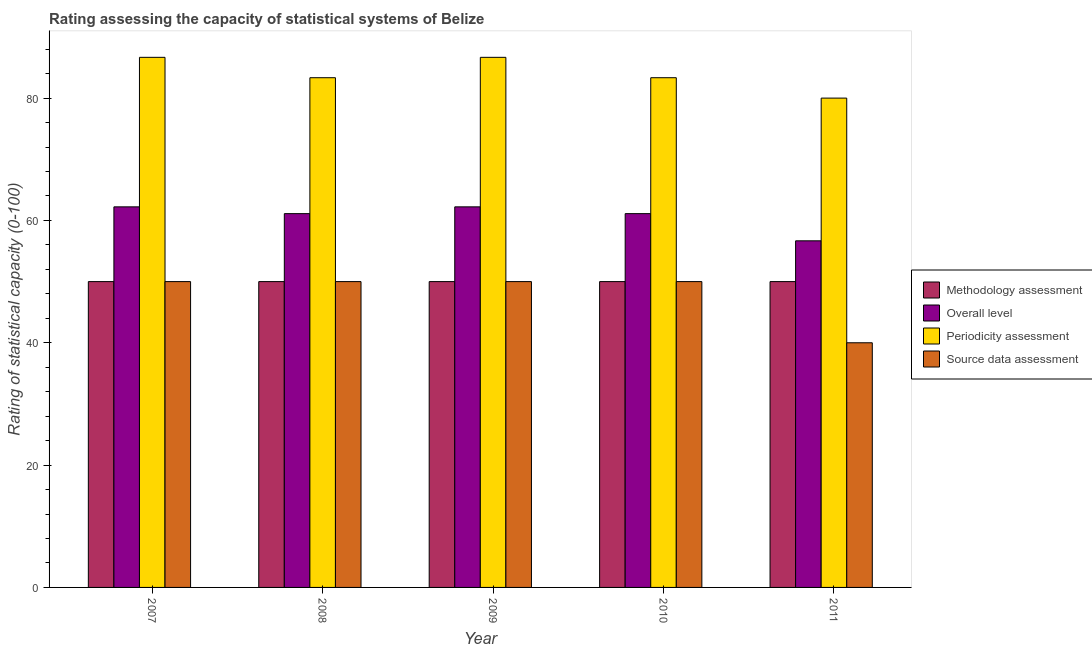How many groups of bars are there?
Offer a terse response. 5. How many bars are there on the 2nd tick from the left?
Offer a terse response. 4. In how many cases, is the number of bars for a given year not equal to the number of legend labels?
Offer a terse response. 0. What is the periodicity assessment rating in 2008?
Offer a terse response. 83.33. Across all years, what is the maximum periodicity assessment rating?
Keep it short and to the point. 86.67. Across all years, what is the minimum methodology assessment rating?
Offer a terse response. 50. In which year was the methodology assessment rating maximum?
Offer a terse response. 2007. What is the total overall level rating in the graph?
Provide a succinct answer. 303.33. What is the difference between the source data assessment rating in 2007 and that in 2011?
Your answer should be very brief. 10. What is the difference between the periodicity assessment rating in 2008 and the methodology assessment rating in 2007?
Your answer should be very brief. -3.33. In how many years, is the methodology assessment rating greater than 76?
Keep it short and to the point. 0. Is the source data assessment rating in 2009 less than that in 2010?
Provide a short and direct response. No. What is the difference between the highest and the second highest periodicity assessment rating?
Offer a very short reply. 0. What is the difference between the highest and the lowest source data assessment rating?
Provide a short and direct response. 10. In how many years, is the methodology assessment rating greater than the average methodology assessment rating taken over all years?
Provide a succinct answer. 0. Is the sum of the periodicity assessment rating in 2007 and 2008 greater than the maximum methodology assessment rating across all years?
Offer a very short reply. Yes. Is it the case that in every year, the sum of the periodicity assessment rating and overall level rating is greater than the sum of methodology assessment rating and source data assessment rating?
Offer a terse response. Yes. What does the 3rd bar from the left in 2009 represents?
Make the answer very short. Periodicity assessment. What does the 1st bar from the right in 2007 represents?
Offer a terse response. Source data assessment. How many bars are there?
Give a very brief answer. 20. Are all the bars in the graph horizontal?
Offer a very short reply. No. What is the difference between two consecutive major ticks on the Y-axis?
Offer a terse response. 20. Does the graph contain grids?
Your response must be concise. No. Where does the legend appear in the graph?
Make the answer very short. Center right. How are the legend labels stacked?
Ensure brevity in your answer.  Vertical. What is the title of the graph?
Give a very brief answer. Rating assessing the capacity of statistical systems of Belize. Does "Permission" appear as one of the legend labels in the graph?
Make the answer very short. No. What is the label or title of the X-axis?
Give a very brief answer. Year. What is the label or title of the Y-axis?
Offer a very short reply. Rating of statistical capacity (0-100). What is the Rating of statistical capacity (0-100) of Overall level in 2007?
Ensure brevity in your answer.  62.22. What is the Rating of statistical capacity (0-100) in Periodicity assessment in 2007?
Make the answer very short. 86.67. What is the Rating of statistical capacity (0-100) in Methodology assessment in 2008?
Make the answer very short. 50. What is the Rating of statistical capacity (0-100) in Overall level in 2008?
Give a very brief answer. 61.11. What is the Rating of statistical capacity (0-100) in Periodicity assessment in 2008?
Provide a short and direct response. 83.33. What is the Rating of statistical capacity (0-100) in Source data assessment in 2008?
Give a very brief answer. 50. What is the Rating of statistical capacity (0-100) of Overall level in 2009?
Keep it short and to the point. 62.22. What is the Rating of statistical capacity (0-100) in Periodicity assessment in 2009?
Your answer should be compact. 86.67. What is the Rating of statistical capacity (0-100) of Methodology assessment in 2010?
Provide a succinct answer. 50. What is the Rating of statistical capacity (0-100) in Overall level in 2010?
Keep it short and to the point. 61.11. What is the Rating of statistical capacity (0-100) of Periodicity assessment in 2010?
Ensure brevity in your answer.  83.33. What is the Rating of statistical capacity (0-100) of Overall level in 2011?
Offer a terse response. 56.67. Across all years, what is the maximum Rating of statistical capacity (0-100) in Overall level?
Give a very brief answer. 62.22. Across all years, what is the maximum Rating of statistical capacity (0-100) in Periodicity assessment?
Your answer should be compact. 86.67. Across all years, what is the maximum Rating of statistical capacity (0-100) in Source data assessment?
Your response must be concise. 50. Across all years, what is the minimum Rating of statistical capacity (0-100) of Methodology assessment?
Ensure brevity in your answer.  50. Across all years, what is the minimum Rating of statistical capacity (0-100) in Overall level?
Give a very brief answer. 56.67. Across all years, what is the minimum Rating of statistical capacity (0-100) of Periodicity assessment?
Your answer should be very brief. 80. What is the total Rating of statistical capacity (0-100) of Methodology assessment in the graph?
Give a very brief answer. 250. What is the total Rating of statistical capacity (0-100) of Overall level in the graph?
Provide a short and direct response. 303.33. What is the total Rating of statistical capacity (0-100) of Periodicity assessment in the graph?
Your answer should be very brief. 420. What is the total Rating of statistical capacity (0-100) in Source data assessment in the graph?
Provide a short and direct response. 240. What is the difference between the Rating of statistical capacity (0-100) in Overall level in 2007 and that in 2008?
Offer a very short reply. 1.11. What is the difference between the Rating of statistical capacity (0-100) in Source data assessment in 2007 and that in 2008?
Your answer should be compact. 0. What is the difference between the Rating of statistical capacity (0-100) of Methodology assessment in 2007 and that in 2009?
Your answer should be very brief. 0. What is the difference between the Rating of statistical capacity (0-100) in Periodicity assessment in 2007 and that in 2010?
Give a very brief answer. 3.33. What is the difference between the Rating of statistical capacity (0-100) of Source data assessment in 2007 and that in 2010?
Keep it short and to the point. 0. What is the difference between the Rating of statistical capacity (0-100) of Overall level in 2007 and that in 2011?
Your answer should be very brief. 5.56. What is the difference between the Rating of statistical capacity (0-100) of Source data assessment in 2007 and that in 2011?
Give a very brief answer. 10. What is the difference between the Rating of statistical capacity (0-100) of Overall level in 2008 and that in 2009?
Ensure brevity in your answer.  -1.11. What is the difference between the Rating of statistical capacity (0-100) of Source data assessment in 2008 and that in 2009?
Keep it short and to the point. 0. What is the difference between the Rating of statistical capacity (0-100) in Methodology assessment in 2008 and that in 2010?
Offer a very short reply. 0. What is the difference between the Rating of statistical capacity (0-100) of Overall level in 2008 and that in 2010?
Give a very brief answer. 0. What is the difference between the Rating of statistical capacity (0-100) of Source data assessment in 2008 and that in 2010?
Provide a short and direct response. 0. What is the difference between the Rating of statistical capacity (0-100) of Methodology assessment in 2008 and that in 2011?
Make the answer very short. 0. What is the difference between the Rating of statistical capacity (0-100) in Overall level in 2008 and that in 2011?
Keep it short and to the point. 4.44. What is the difference between the Rating of statistical capacity (0-100) of Source data assessment in 2008 and that in 2011?
Keep it short and to the point. 10. What is the difference between the Rating of statistical capacity (0-100) in Methodology assessment in 2009 and that in 2010?
Your response must be concise. 0. What is the difference between the Rating of statistical capacity (0-100) of Overall level in 2009 and that in 2010?
Provide a succinct answer. 1.11. What is the difference between the Rating of statistical capacity (0-100) of Periodicity assessment in 2009 and that in 2010?
Give a very brief answer. 3.33. What is the difference between the Rating of statistical capacity (0-100) in Overall level in 2009 and that in 2011?
Your answer should be compact. 5.56. What is the difference between the Rating of statistical capacity (0-100) of Source data assessment in 2009 and that in 2011?
Provide a short and direct response. 10. What is the difference between the Rating of statistical capacity (0-100) of Methodology assessment in 2010 and that in 2011?
Provide a short and direct response. 0. What is the difference between the Rating of statistical capacity (0-100) of Overall level in 2010 and that in 2011?
Your answer should be compact. 4.44. What is the difference between the Rating of statistical capacity (0-100) in Periodicity assessment in 2010 and that in 2011?
Keep it short and to the point. 3.33. What is the difference between the Rating of statistical capacity (0-100) of Source data assessment in 2010 and that in 2011?
Provide a short and direct response. 10. What is the difference between the Rating of statistical capacity (0-100) of Methodology assessment in 2007 and the Rating of statistical capacity (0-100) of Overall level in 2008?
Provide a succinct answer. -11.11. What is the difference between the Rating of statistical capacity (0-100) of Methodology assessment in 2007 and the Rating of statistical capacity (0-100) of Periodicity assessment in 2008?
Offer a very short reply. -33.33. What is the difference between the Rating of statistical capacity (0-100) of Overall level in 2007 and the Rating of statistical capacity (0-100) of Periodicity assessment in 2008?
Provide a short and direct response. -21.11. What is the difference between the Rating of statistical capacity (0-100) of Overall level in 2007 and the Rating of statistical capacity (0-100) of Source data assessment in 2008?
Make the answer very short. 12.22. What is the difference between the Rating of statistical capacity (0-100) of Periodicity assessment in 2007 and the Rating of statistical capacity (0-100) of Source data assessment in 2008?
Your answer should be compact. 36.67. What is the difference between the Rating of statistical capacity (0-100) in Methodology assessment in 2007 and the Rating of statistical capacity (0-100) in Overall level in 2009?
Provide a short and direct response. -12.22. What is the difference between the Rating of statistical capacity (0-100) in Methodology assessment in 2007 and the Rating of statistical capacity (0-100) in Periodicity assessment in 2009?
Provide a succinct answer. -36.67. What is the difference between the Rating of statistical capacity (0-100) in Overall level in 2007 and the Rating of statistical capacity (0-100) in Periodicity assessment in 2009?
Keep it short and to the point. -24.44. What is the difference between the Rating of statistical capacity (0-100) of Overall level in 2007 and the Rating of statistical capacity (0-100) of Source data assessment in 2009?
Your answer should be very brief. 12.22. What is the difference between the Rating of statistical capacity (0-100) of Periodicity assessment in 2007 and the Rating of statistical capacity (0-100) of Source data assessment in 2009?
Your response must be concise. 36.67. What is the difference between the Rating of statistical capacity (0-100) in Methodology assessment in 2007 and the Rating of statistical capacity (0-100) in Overall level in 2010?
Ensure brevity in your answer.  -11.11. What is the difference between the Rating of statistical capacity (0-100) of Methodology assessment in 2007 and the Rating of statistical capacity (0-100) of Periodicity assessment in 2010?
Make the answer very short. -33.33. What is the difference between the Rating of statistical capacity (0-100) of Methodology assessment in 2007 and the Rating of statistical capacity (0-100) of Source data assessment in 2010?
Ensure brevity in your answer.  0. What is the difference between the Rating of statistical capacity (0-100) in Overall level in 2007 and the Rating of statistical capacity (0-100) in Periodicity assessment in 2010?
Ensure brevity in your answer.  -21.11. What is the difference between the Rating of statistical capacity (0-100) of Overall level in 2007 and the Rating of statistical capacity (0-100) of Source data assessment in 2010?
Give a very brief answer. 12.22. What is the difference between the Rating of statistical capacity (0-100) in Periodicity assessment in 2007 and the Rating of statistical capacity (0-100) in Source data assessment in 2010?
Offer a terse response. 36.67. What is the difference between the Rating of statistical capacity (0-100) in Methodology assessment in 2007 and the Rating of statistical capacity (0-100) in Overall level in 2011?
Offer a very short reply. -6.67. What is the difference between the Rating of statistical capacity (0-100) of Overall level in 2007 and the Rating of statistical capacity (0-100) of Periodicity assessment in 2011?
Your answer should be very brief. -17.78. What is the difference between the Rating of statistical capacity (0-100) of Overall level in 2007 and the Rating of statistical capacity (0-100) of Source data assessment in 2011?
Give a very brief answer. 22.22. What is the difference between the Rating of statistical capacity (0-100) of Periodicity assessment in 2007 and the Rating of statistical capacity (0-100) of Source data assessment in 2011?
Keep it short and to the point. 46.67. What is the difference between the Rating of statistical capacity (0-100) in Methodology assessment in 2008 and the Rating of statistical capacity (0-100) in Overall level in 2009?
Your answer should be very brief. -12.22. What is the difference between the Rating of statistical capacity (0-100) of Methodology assessment in 2008 and the Rating of statistical capacity (0-100) of Periodicity assessment in 2009?
Give a very brief answer. -36.67. What is the difference between the Rating of statistical capacity (0-100) in Overall level in 2008 and the Rating of statistical capacity (0-100) in Periodicity assessment in 2009?
Provide a short and direct response. -25.56. What is the difference between the Rating of statistical capacity (0-100) of Overall level in 2008 and the Rating of statistical capacity (0-100) of Source data assessment in 2009?
Provide a succinct answer. 11.11. What is the difference between the Rating of statistical capacity (0-100) in Periodicity assessment in 2008 and the Rating of statistical capacity (0-100) in Source data assessment in 2009?
Provide a short and direct response. 33.33. What is the difference between the Rating of statistical capacity (0-100) of Methodology assessment in 2008 and the Rating of statistical capacity (0-100) of Overall level in 2010?
Your response must be concise. -11.11. What is the difference between the Rating of statistical capacity (0-100) in Methodology assessment in 2008 and the Rating of statistical capacity (0-100) in Periodicity assessment in 2010?
Provide a succinct answer. -33.33. What is the difference between the Rating of statistical capacity (0-100) of Overall level in 2008 and the Rating of statistical capacity (0-100) of Periodicity assessment in 2010?
Give a very brief answer. -22.22. What is the difference between the Rating of statistical capacity (0-100) of Overall level in 2008 and the Rating of statistical capacity (0-100) of Source data assessment in 2010?
Provide a short and direct response. 11.11. What is the difference between the Rating of statistical capacity (0-100) in Periodicity assessment in 2008 and the Rating of statistical capacity (0-100) in Source data assessment in 2010?
Your answer should be very brief. 33.33. What is the difference between the Rating of statistical capacity (0-100) of Methodology assessment in 2008 and the Rating of statistical capacity (0-100) of Overall level in 2011?
Offer a very short reply. -6.67. What is the difference between the Rating of statistical capacity (0-100) of Methodology assessment in 2008 and the Rating of statistical capacity (0-100) of Periodicity assessment in 2011?
Provide a succinct answer. -30. What is the difference between the Rating of statistical capacity (0-100) of Methodology assessment in 2008 and the Rating of statistical capacity (0-100) of Source data assessment in 2011?
Provide a succinct answer. 10. What is the difference between the Rating of statistical capacity (0-100) in Overall level in 2008 and the Rating of statistical capacity (0-100) in Periodicity assessment in 2011?
Keep it short and to the point. -18.89. What is the difference between the Rating of statistical capacity (0-100) in Overall level in 2008 and the Rating of statistical capacity (0-100) in Source data assessment in 2011?
Your response must be concise. 21.11. What is the difference between the Rating of statistical capacity (0-100) in Periodicity assessment in 2008 and the Rating of statistical capacity (0-100) in Source data assessment in 2011?
Keep it short and to the point. 43.33. What is the difference between the Rating of statistical capacity (0-100) of Methodology assessment in 2009 and the Rating of statistical capacity (0-100) of Overall level in 2010?
Keep it short and to the point. -11.11. What is the difference between the Rating of statistical capacity (0-100) in Methodology assessment in 2009 and the Rating of statistical capacity (0-100) in Periodicity assessment in 2010?
Offer a very short reply. -33.33. What is the difference between the Rating of statistical capacity (0-100) in Methodology assessment in 2009 and the Rating of statistical capacity (0-100) in Source data assessment in 2010?
Offer a terse response. 0. What is the difference between the Rating of statistical capacity (0-100) of Overall level in 2009 and the Rating of statistical capacity (0-100) of Periodicity assessment in 2010?
Your answer should be very brief. -21.11. What is the difference between the Rating of statistical capacity (0-100) in Overall level in 2009 and the Rating of statistical capacity (0-100) in Source data assessment in 2010?
Keep it short and to the point. 12.22. What is the difference between the Rating of statistical capacity (0-100) of Periodicity assessment in 2009 and the Rating of statistical capacity (0-100) of Source data assessment in 2010?
Give a very brief answer. 36.67. What is the difference between the Rating of statistical capacity (0-100) in Methodology assessment in 2009 and the Rating of statistical capacity (0-100) in Overall level in 2011?
Make the answer very short. -6.67. What is the difference between the Rating of statistical capacity (0-100) in Methodology assessment in 2009 and the Rating of statistical capacity (0-100) in Periodicity assessment in 2011?
Ensure brevity in your answer.  -30. What is the difference between the Rating of statistical capacity (0-100) in Overall level in 2009 and the Rating of statistical capacity (0-100) in Periodicity assessment in 2011?
Make the answer very short. -17.78. What is the difference between the Rating of statistical capacity (0-100) of Overall level in 2009 and the Rating of statistical capacity (0-100) of Source data assessment in 2011?
Give a very brief answer. 22.22. What is the difference between the Rating of statistical capacity (0-100) of Periodicity assessment in 2009 and the Rating of statistical capacity (0-100) of Source data assessment in 2011?
Keep it short and to the point. 46.67. What is the difference between the Rating of statistical capacity (0-100) of Methodology assessment in 2010 and the Rating of statistical capacity (0-100) of Overall level in 2011?
Your response must be concise. -6.67. What is the difference between the Rating of statistical capacity (0-100) of Overall level in 2010 and the Rating of statistical capacity (0-100) of Periodicity assessment in 2011?
Offer a terse response. -18.89. What is the difference between the Rating of statistical capacity (0-100) in Overall level in 2010 and the Rating of statistical capacity (0-100) in Source data assessment in 2011?
Provide a succinct answer. 21.11. What is the difference between the Rating of statistical capacity (0-100) of Periodicity assessment in 2010 and the Rating of statistical capacity (0-100) of Source data assessment in 2011?
Your answer should be very brief. 43.33. What is the average Rating of statistical capacity (0-100) of Methodology assessment per year?
Ensure brevity in your answer.  50. What is the average Rating of statistical capacity (0-100) in Overall level per year?
Your answer should be compact. 60.67. In the year 2007, what is the difference between the Rating of statistical capacity (0-100) of Methodology assessment and Rating of statistical capacity (0-100) of Overall level?
Your answer should be compact. -12.22. In the year 2007, what is the difference between the Rating of statistical capacity (0-100) of Methodology assessment and Rating of statistical capacity (0-100) of Periodicity assessment?
Ensure brevity in your answer.  -36.67. In the year 2007, what is the difference between the Rating of statistical capacity (0-100) in Methodology assessment and Rating of statistical capacity (0-100) in Source data assessment?
Your answer should be very brief. 0. In the year 2007, what is the difference between the Rating of statistical capacity (0-100) of Overall level and Rating of statistical capacity (0-100) of Periodicity assessment?
Your response must be concise. -24.44. In the year 2007, what is the difference between the Rating of statistical capacity (0-100) in Overall level and Rating of statistical capacity (0-100) in Source data assessment?
Make the answer very short. 12.22. In the year 2007, what is the difference between the Rating of statistical capacity (0-100) in Periodicity assessment and Rating of statistical capacity (0-100) in Source data assessment?
Ensure brevity in your answer.  36.67. In the year 2008, what is the difference between the Rating of statistical capacity (0-100) of Methodology assessment and Rating of statistical capacity (0-100) of Overall level?
Keep it short and to the point. -11.11. In the year 2008, what is the difference between the Rating of statistical capacity (0-100) of Methodology assessment and Rating of statistical capacity (0-100) of Periodicity assessment?
Make the answer very short. -33.33. In the year 2008, what is the difference between the Rating of statistical capacity (0-100) in Methodology assessment and Rating of statistical capacity (0-100) in Source data assessment?
Give a very brief answer. 0. In the year 2008, what is the difference between the Rating of statistical capacity (0-100) of Overall level and Rating of statistical capacity (0-100) of Periodicity assessment?
Provide a short and direct response. -22.22. In the year 2008, what is the difference between the Rating of statistical capacity (0-100) of Overall level and Rating of statistical capacity (0-100) of Source data assessment?
Ensure brevity in your answer.  11.11. In the year 2008, what is the difference between the Rating of statistical capacity (0-100) of Periodicity assessment and Rating of statistical capacity (0-100) of Source data assessment?
Ensure brevity in your answer.  33.33. In the year 2009, what is the difference between the Rating of statistical capacity (0-100) in Methodology assessment and Rating of statistical capacity (0-100) in Overall level?
Ensure brevity in your answer.  -12.22. In the year 2009, what is the difference between the Rating of statistical capacity (0-100) in Methodology assessment and Rating of statistical capacity (0-100) in Periodicity assessment?
Your answer should be very brief. -36.67. In the year 2009, what is the difference between the Rating of statistical capacity (0-100) in Overall level and Rating of statistical capacity (0-100) in Periodicity assessment?
Your answer should be very brief. -24.44. In the year 2009, what is the difference between the Rating of statistical capacity (0-100) of Overall level and Rating of statistical capacity (0-100) of Source data assessment?
Offer a terse response. 12.22. In the year 2009, what is the difference between the Rating of statistical capacity (0-100) in Periodicity assessment and Rating of statistical capacity (0-100) in Source data assessment?
Ensure brevity in your answer.  36.67. In the year 2010, what is the difference between the Rating of statistical capacity (0-100) in Methodology assessment and Rating of statistical capacity (0-100) in Overall level?
Offer a very short reply. -11.11. In the year 2010, what is the difference between the Rating of statistical capacity (0-100) of Methodology assessment and Rating of statistical capacity (0-100) of Periodicity assessment?
Make the answer very short. -33.33. In the year 2010, what is the difference between the Rating of statistical capacity (0-100) in Methodology assessment and Rating of statistical capacity (0-100) in Source data assessment?
Your response must be concise. 0. In the year 2010, what is the difference between the Rating of statistical capacity (0-100) in Overall level and Rating of statistical capacity (0-100) in Periodicity assessment?
Make the answer very short. -22.22. In the year 2010, what is the difference between the Rating of statistical capacity (0-100) of Overall level and Rating of statistical capacity (0-100) of Source data assessment?
Offer a very short reply. 11.11. In the year 2010, what is the difference between the Rating of statistical capacity (0-100) in Periodicity assessment and Rating of statistical capacity (0-100) in Source data assessment?
Ensure brevity in your answer.  33.33. In the year 2011, what is the difference between the Rating of statistical capacity (0-100) of Methodology assessment and Rating of statistical capacity (0-100) of Overall level?
Your answer should be very brief. -6.67. In the year 2011, what is the difference between the Rating of statistical capacity (0-100) of Methodology assessment and Rating of statistical capacity (0-100) of Periodicity assessment?
Your answer should be very brief. -30. In the year 2011, what is the difference between the Rating of statistical capacity (0-100) in Methodology assessment and Rating of statistical capacity (0-100) in Source data assessment?
Give a very brief answer. 10. In the year 2011, what is the difference between the Rating of statistical capacity (0-100) in Overall level and Rating of statistical capacity (0-100) in Periodicity assessment?
Your answer should be compact. -23.33. In the year 2011, what is the difference between the Rating of statistical capacity (0-100) of Overall level and Rating of statistical capacity (0-100) of Source data assessment?
Provide a short and direct response. 16.67. In the year 2011, what is the difference between the Rating of statistical capacity (0-100) of Periodicity assessment and Rating of statistical capacity (0-100) of Source data assessment?
Your answer should be compact. 40. What is the ratio of the Rating of statistical capacity (0-100) in Overall level in 2007 to that in 2008?
Keep it short and to the point. 1.02. What is the ratio of the Rating of statistical capacity (0-100) of Source data assessment in 2007 to that in 2008?
Ensure brevity in your answer.  1. What is the ratio of the Rating of statistical capacity (0-100) of Methodology assessment in 2007 to that in 2009?
Make the answer very short. 1. What is the ratio of the Rating of statistical capacity (0-100) of Overall level in 2007 to that in 2009?
Give a very brief answer. 1. What is the ratio of the Rating of statistical capacity (0-100) in Source data assessment in 2007 to that in 2009?
Offer a terse response. 1. What is the ratio of the Rating of statistical capacity (0-100) of Methodology assessment in 2007 to that in 2010?
Provide a short and direct response. 1. What is the ratio of the Rating of statistical capacity (0-100) of Overall level in 2007 to that in 2010?
Ensure brevity in your answer.  1.02. What is the ratio of the Rating of statistical capacity (0-100) of Periodicity assessment in 2007 to that in 2010?
Your answer should be compact. 1.04. What is the ratio of the Rating of statistical capacity (0-100) of Overall level in 2007 to that in 2011?
Your answer should be very brief. 1.1. What is the ratio of the Rating of statistical capacity (0-100) in Periodicity assessment in 2007 to that in 2011?
Provide a succinct answer. 1.08. What is the ratio of the Rating of statistical capacity (0-100) of Methodology assessment in 2008 to that in 2009?
Your response must be concise. 1. What is the ratio of the Rating of statistical capacity (0-100) in Overall level in 2008 to that in 2009?
Offer a terse response. 0.98. What is the ratio of the Rating of statistical capacity (0-100) of Periodicity assessment in 2008 to that in 2009?
Your response must be concise. 0.96. What is the ratio of the Rating of statistical capacity (0-100) in Source data assessment in 2008 to that in 2009?
Keep it short and to the point. 1. What is the ratio of the Rating of statistical capacity (0-100) of Methodology assessment in 2008 to that in 2010?
Provide a succinct answer. 1. What is the ratio of the Rating of statistical capacity (0-100) of Overall level in 2008 to that in 2010?
Your answer should be compact. 1. What is the ratio of the Rating of statistical capacity (0-100) in Periodicity assessment in 2008 to that in 2010?
Provide a short and direct response. 1. What is the ratio of the Rating of statistical capacity (0-100) in Overall level in 2008 to that in 2011?
Make the answer very short. 1.08. What is the ratio of the Rating of statistical capacity (0-100) in Periodicity assessment in 2008 to that in 2011?
Provide a succinct answer. 1.04. What is the ratio of the Rating of statistical capacity (0-100) of Source data assessment in 2008 to that in 2011?
Offer a terse response. 1.25. What is the ratio of the Rating of statistical capacity (0-100) of Overall level in 2009 to that in 2010?
Keep it short and to the point. 1.02. What is the ratio of the Rating of statistical capacity (0-100) in Source data assessment in 2009 to that in 2010?
Your answer should be compact. 1. What is the ratio of the Rating of statistical capacity (0-100) in Overall level in 2009 to that in 2011?
Offer a very short reply. 1.1. What is the ratio of the Rating of statistical capacity (0-100) of Source data assessment in 2009 to that in 2011?
Keep it short and to the point. 1.25. What is the ratio of the Rating of statistical capacity (0-100) of Overall level in 2010 to that in 2011?
Your answer should be compact. 1.08. What is the ratio of the Rating of statistical capacity (0-100) of Periodicity assessment in 2010 to that in 2011?
Ensure brevity in your answer.  1.04. What is the ratio of the Rating of statistical capacity (0-100) of Source data assessment in 2010 to that in 2011?
Ensure brevity in your answer.  1.25. What is the difference between the highest and the second highest Rating of statistical capacity (0-100) of Overall level?
Make the answer very short. 0. What is the difference between the highest and the second highest Rating of statistical capacity (0-100) in Periodicity assessment?
Offer a terse response. 0. What is the difference between the highest and the second highest Rating of statistical capacity (0-100) of Source data assessment?
Ensure brevity in your answer.  0. What is the difference between the highest and the lowest Rating of statistical capacity (0-100) in Overall level?
Ensure brevity in your answer.  5.56. 